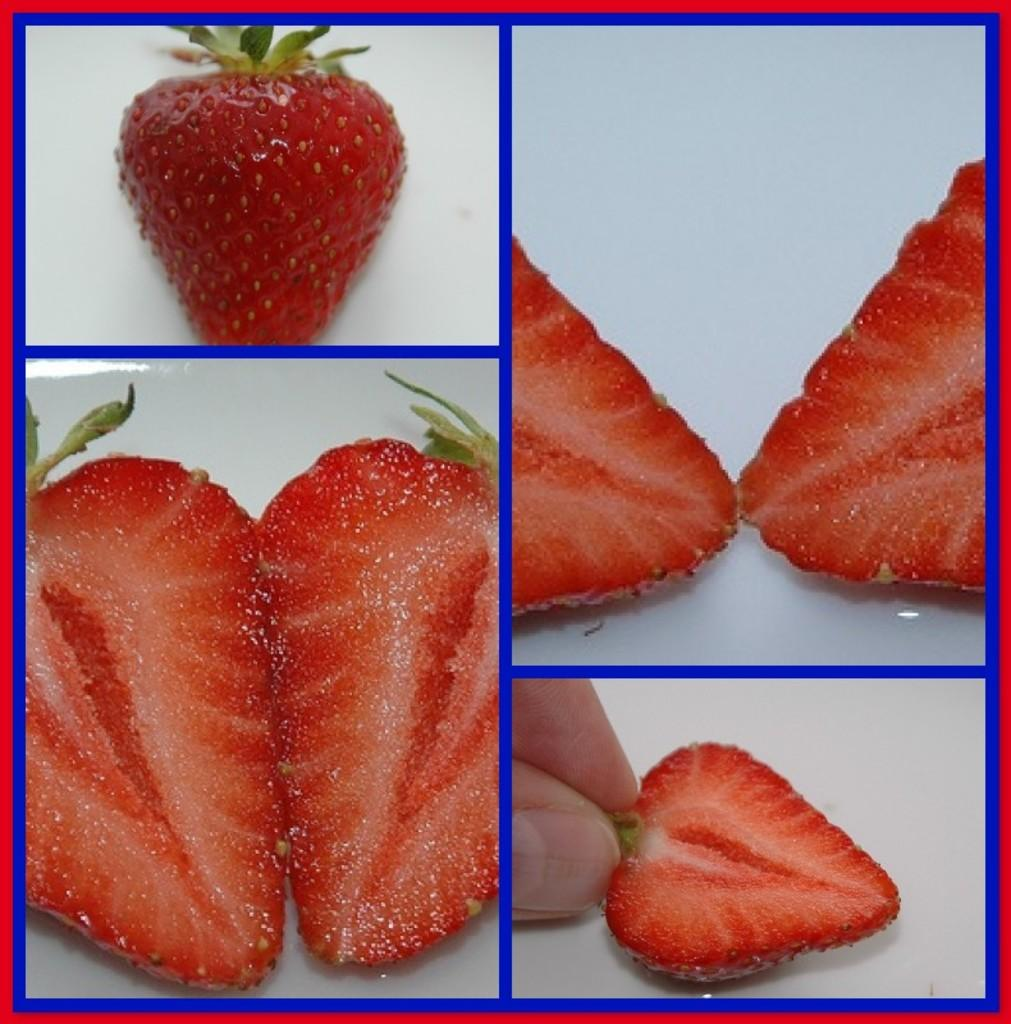What is the main subject of the picture? The main subject of the picture is a strawberry. How is the strawberry depicted in the image? The strawberry is cut into two pieces in the image. What is the person's hand doing in the image? The person's hand is holding a slice of the strawberry. What type of bell can be heard ringing in the image? There is no bell present in the image, and therefore no sound can be heard. 